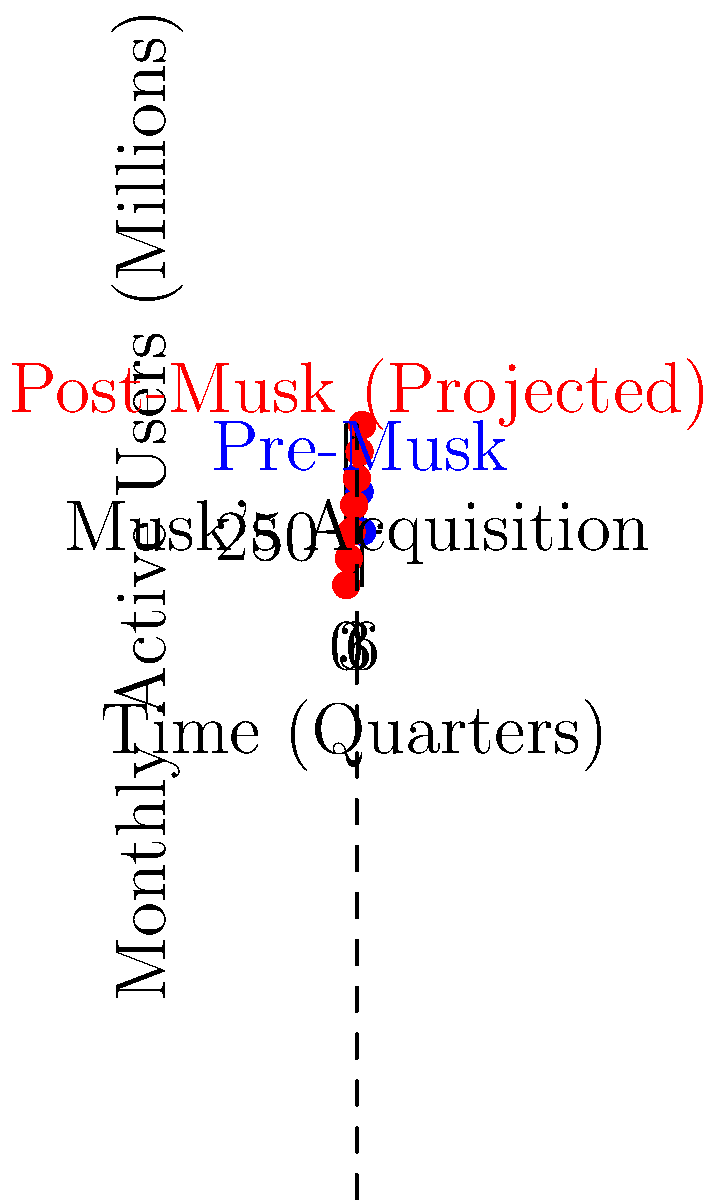Analyzing the line graph showing Twitter's user growth trends before and after Elon Musk's acquisition, what critical observation can be made about the actual user growth compared to the projected growth, and how might this relate to Musk's influence on the platform? To answer this question, let's analyze the graph step-by-step:

1. The blue line represents Twitter's user growth before Musk's acquisition, while the red line shows projected growth after the acquisition.

2. The vertical dashed line indicates the point of Musk's acquisition, which occurs at the 4th quarter mark.

3. Pre-acquisition trend (blue line):
   - Shows steady growth from 230 million to 270 million monthly active users over 4 quarters.
   - Begins to decline slightly in the last quarter before acquisition.

4. Post-acquisition projected trend (red line):
   - Continues the pre-acquisition growth trajectory.
   - Reaches 290 million users by the end of the 6th quarter.

5. Actual post-acquisition trend (blue line continuation):
   - Deviates significantly from the projected growth.
   - Shows a sharp decline, dropping to 250 million users by the end of the 6th quarter.

6. Critical observation:
   - There's a substantial gap between projected and actual user growth after Musk's acquisition.
   - The platform loses approximately 40 million monthly active users compared to projections.

7. Relation to Musk's influence:
   - The deviation coincides with Musk's takeover, suggesting his actions or policies may have impacted user retention and growth.
   - This trend could be linked to controversial changes implemented by Musk, such as content moderation policies, subscription models, or platform functionality alterations.
Answer: Actual user growth significantly underperformed projections post-acquisition, potentially due to Musk's controversial platform changes. 